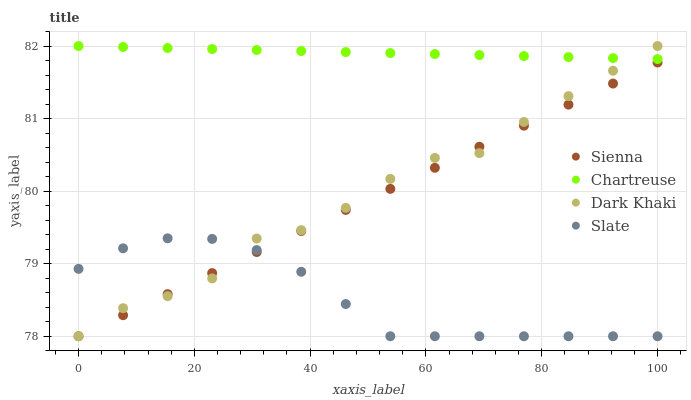Does Slate have the minimum area under the curve?
Answer yes or no. Yes. Does Chartreuse have the maximum area under the curve?
Answer yes or no. Yes. Does Dark Khaki have the minimum area under the curve?
Answer yes or no. No. Does Dark Khaki have the maximum area under the curve?
Answer yes or no. No. Is Chartreuse the smoothest?
Answer yes or no. Yes. Is Dark Khaki the roughest?
Answer yes or no. Yes. Is Dark Khaki the smoothest?
Answer yes or no. No. Is Chartreuse the roughest?
Answer yes or no. No. Does Sienna have the lowest value?
Answer yes or no. Yes. Does Chartreuse have the lowest value?
Answer yes or no. No. Does Chartreuse have the highest value?
Answer yes or no. Yes. Does Slate have the highest value?
Answer yes or no. No. Is Slate less than Chartreuse?
Answer yes or no. Yes. Is Chartreuse greater than Slate?
Answer yes or no. Yes. Does Dark Khaki intersect Slate?
Answer yes or no. Yes. Is Dark Khaki less than Slate?
Answer yes or no. No. Is Dark Khaki greater than Slate?
Answer yes or no. No. Does Slate intersect Chartreuse?
Answer yes or no. No. 